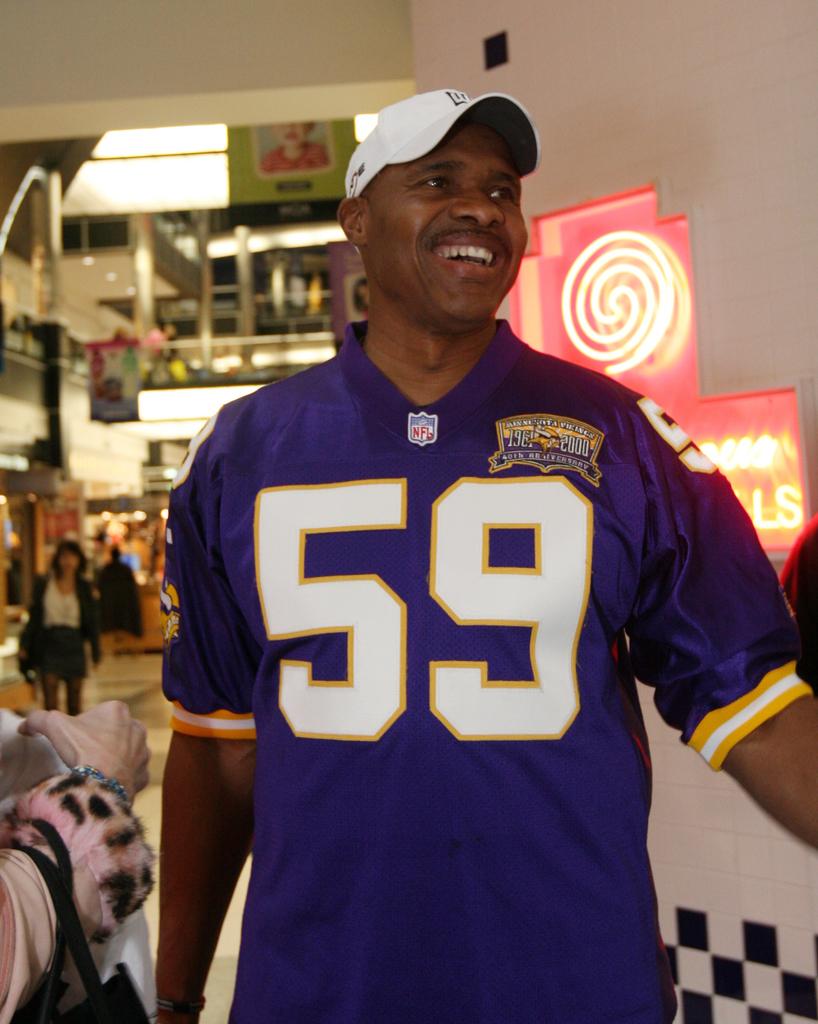What number is on the mans jersey?
Offer a terse response. 59. Is he wearing an nfl jersey?
Make the answer very short. Yes. 